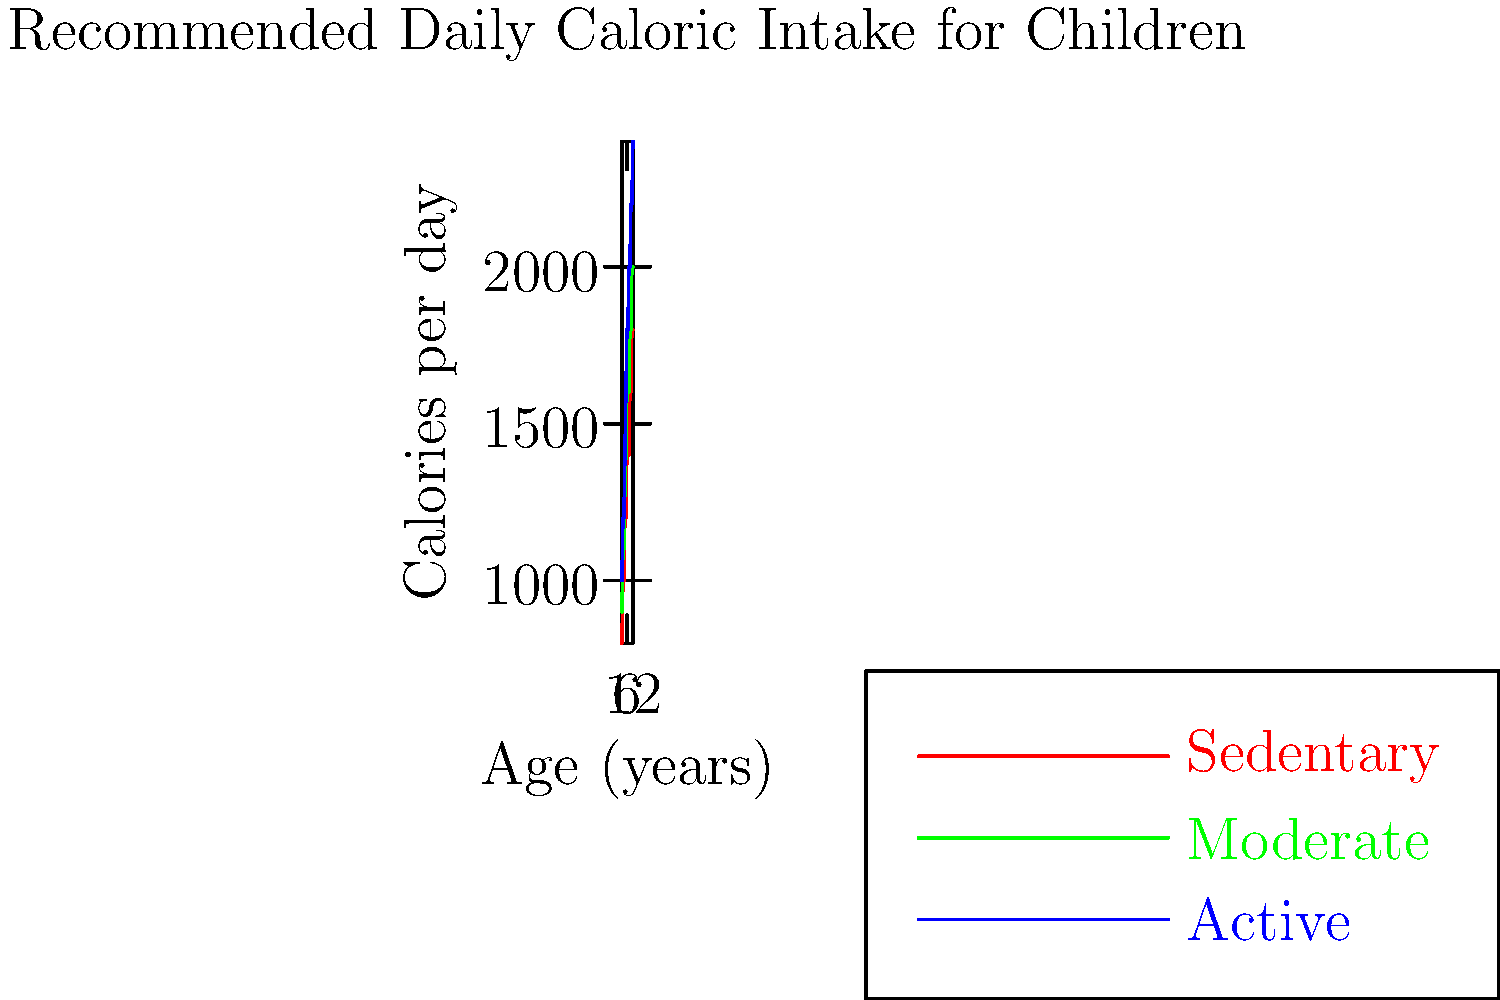Using the graph provided, calculate the difference in recommended daily caloric intake between a moderately active 8-year-old child and a sedentary 5-year-old child. To solve this problem, we need to follow these steps:

1. Identify the recommended daily caloric intake for a moderately active 8-year-old child:
   From the green line (moderate activity) at age 8, we can see that the recommended intake is 1600 calories.

2. Identify the recommended daily caloric intake for a sedentary 5-year-old child:
   From the red line (sedentary) at age 5, we can see that the recommended intake is 1200 calories.

3. Calculate the difference between these two values:
   $\text{Difference} = \text{Moderately active 8-year-old} - \text{Sedentary 5-year-old}$
   $\text{Difference} = 1600 - 1200 = 400 \text{ calories}$

Therefore, the difference in recommended daily caloric intake between a moderately active 8-year-old child and a sedentary 5-year-old child is 400 calories.
Answer: 400 calories 